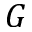<formula> <loc_0><loc_0><loc_500><loc_500>G</formula> 